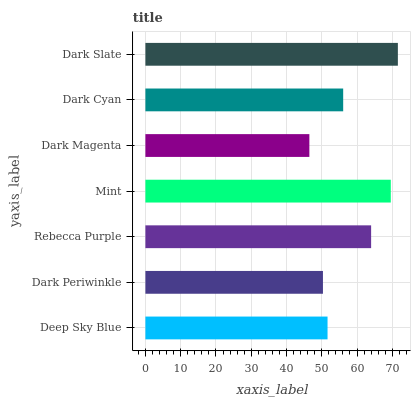Is Dark Magenta the minimum?
Answer yes or no. Yes. Is Dark Slate the maximum?
Answer yes or no. Yes. Is Dark Periwinkle the minimum?
Answer yes or no. No. Is Dark Periwinkle the maximum?
Answer yes or no. No. Is Deep Sky Blue greater than Dark Periwinkle?
Answer yes or no. Yes. Is Dark Periwinkle less than Deep Sky Blue?
Answer yes or no. Yes. Is Dark Periwinkle greater than Deep Sky Blue?
Answer yes or no. No. Is Deep Sky Blue less than Dark Periwinkle?
Answer yes or no. No. Is Dark Cyan the high median?
Answer yes or no. Yes. Is Dark Cyan the low median?
Answer yes or no. Yes. Is Dark Periwinkle the high median?
Answer yes or no. No. Is Deep Sky Blue the low median?
Answer yes or no. No. 